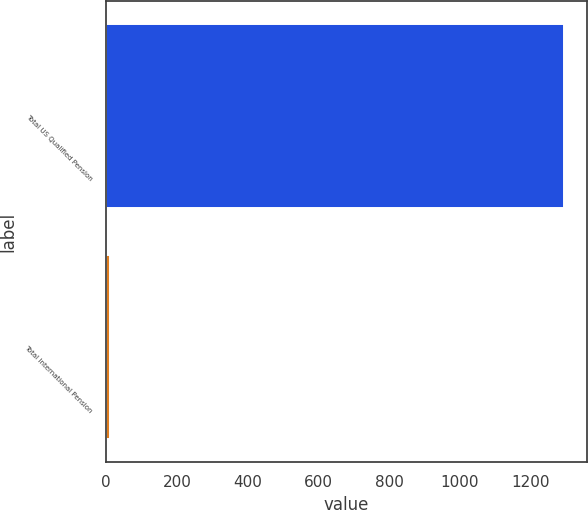Convert chart. <chart><loc_0><loc_0><loc_500><loc_500><bar_chart><fcel>Total US Qualified Pension<fcel>Total International Pension<nl><fcel>1294.8<fcel>11<nl></chart> 